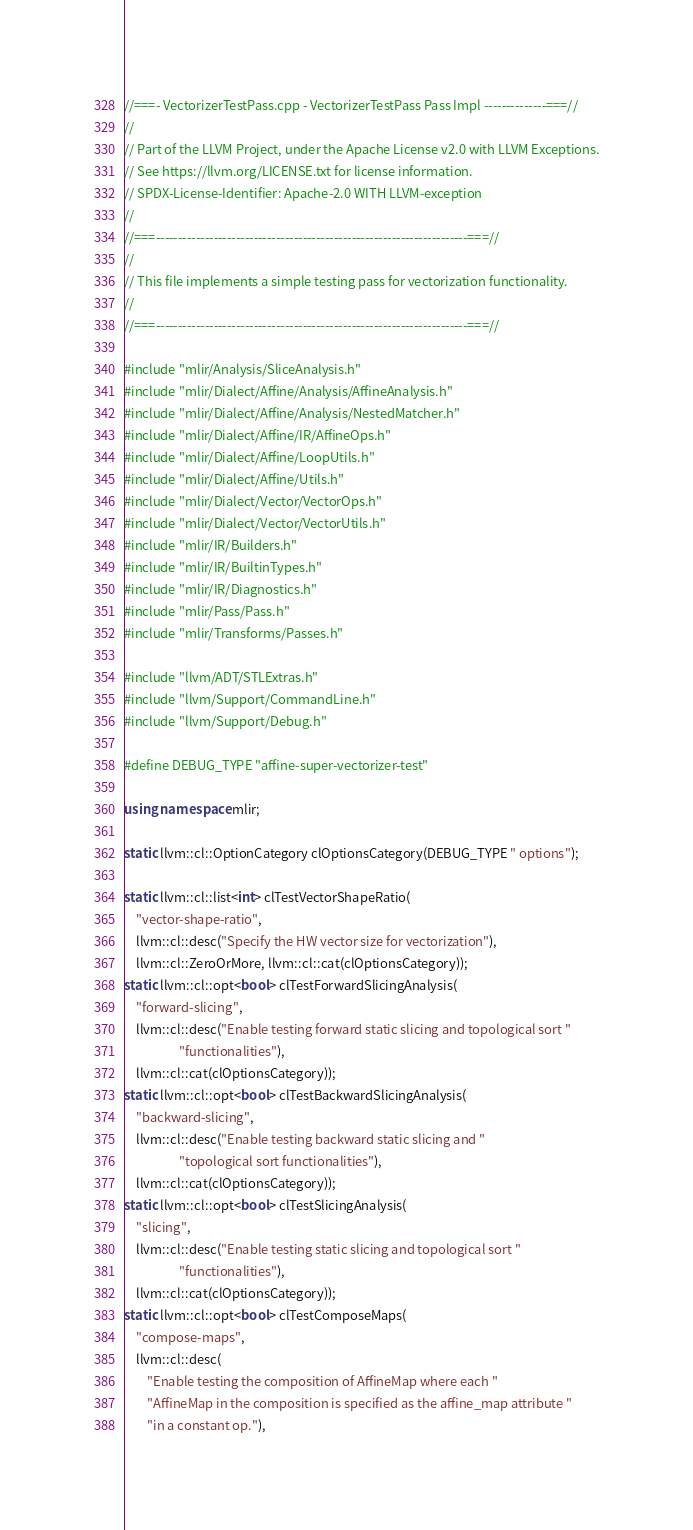Convert code to text. <code><loc_0><loc_0><loc_500><loc_500><_C++_>//===- VectorizerTestPass.cpp - VectorizerTestPass Pass Impl --------------===//
//
// Part of the LLVM Project, under the Apache License v2.0 with LLVM Exceptions.
// See https://llvm.org/LICENSE.txt for license information.
// SPDX-License-Identifier: Apache-2.0 WITH LLVM-exception
//
//===----------------------------------------------------------------------===//
//
// This file implements a simple testing pass for vectorization functionality.
//
//===----------------------------------------------------------------------===//

#include "mlir/Analysis/SliceAnalysis.h"
#include "mlir/Dialect/Affine/Analysis/AffineAnalysis.h"
#include "mlir/Dialect/Affine/Analysis/NestedMatcher.h"
#include "mlir/Dialect/Affine/IR/AffineOps.h"
#include "mlir/Dialect/Affine/LoopUtils.h"
#include "mlir/Dialect/Affine/Utils.h"
#include "mlir/Dialect/Vector/VectorOps.h"
#include "mlir/Dialect/Vector/VectorUtils.h"
#include "mlir/IR/Builders.h"
#include "mlir/IR/BuiltinTypes.h"
#include "mlir/IR/Diagnostics.h"
#include "mlir/Pass/Pass.h"
#include "mlir/Transforms/Passes.h"

#include "llvm/ADT/STLExtras.h"
#include "llvm/Support/CommandLine.h"
#include "llvm/Support/Debug.h"

#define DEBUG_TYPE "affine-super-vectorizer-test"

using namespace mlir;

static llvm::cl::OptionCategory clOptionsCategory(DEBUG_TYPE " options");

static llvm::cl::list<int> clTestVectorShapeRatio(
    "vector-shape-ratio",
    llvm::cl::desc("Specify the HW vector size for vectorization"),
    llvm::cl::ZeroOrMore, llvm::cl::cat(clOptionsCategory));
static llvm::cl::opt<bool> clTestForwardSlicingAnalysis(
    "forward-slicing",
    llvm::cl::desc("Enable testing forward static slicing and topological sort "
                   "functionalities"),
    llvm::cl::cat(clOptionsCategory));
static llvm::cl::opt<bool> clTestBackwardSlicingAnalysis(
    "backward-slicing",
    llvm::cl::desc("Enable testing backward static slicing and "
                   "topological sort functionalities"),
    llvm::cl::cat(clOptionsCategory));
static llvm::cl::opt<bool> clTestSlicingAnalysis(
    "slicing",
    llvm::cl::desc("Enable testing static slicing and topological sort "
                   "functionalities"),
    llvm::cl::cat(clOptionsCategory));
static llvm::cl::opt<bool> clTestComposeMaps(
    "compose-maps",
    llvm::cl::desc(
        "Enable testing the composition of AffineMap where each "
        "AffineMap in the composition is specified as the affine_map attribute "
        "in a constant op."),</code> 